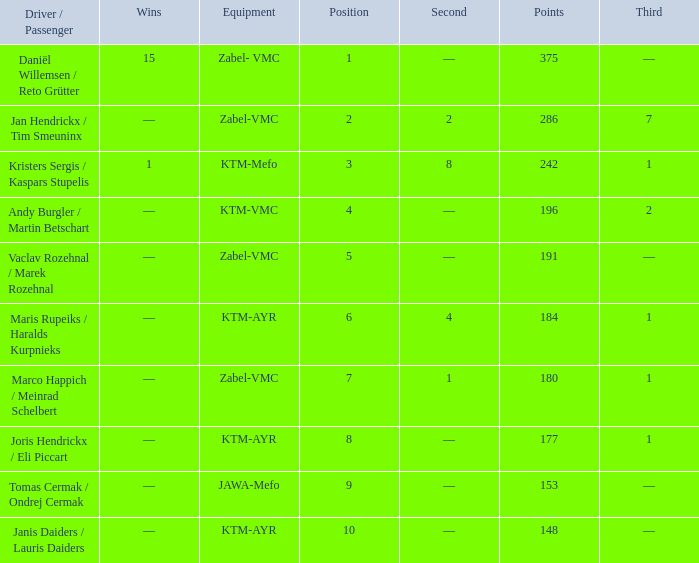Who was the driver/passengar when the position was smaller than 8, the third was 1, and there was 1 win? Kristers Sergis / Kaspars Stupelis. 